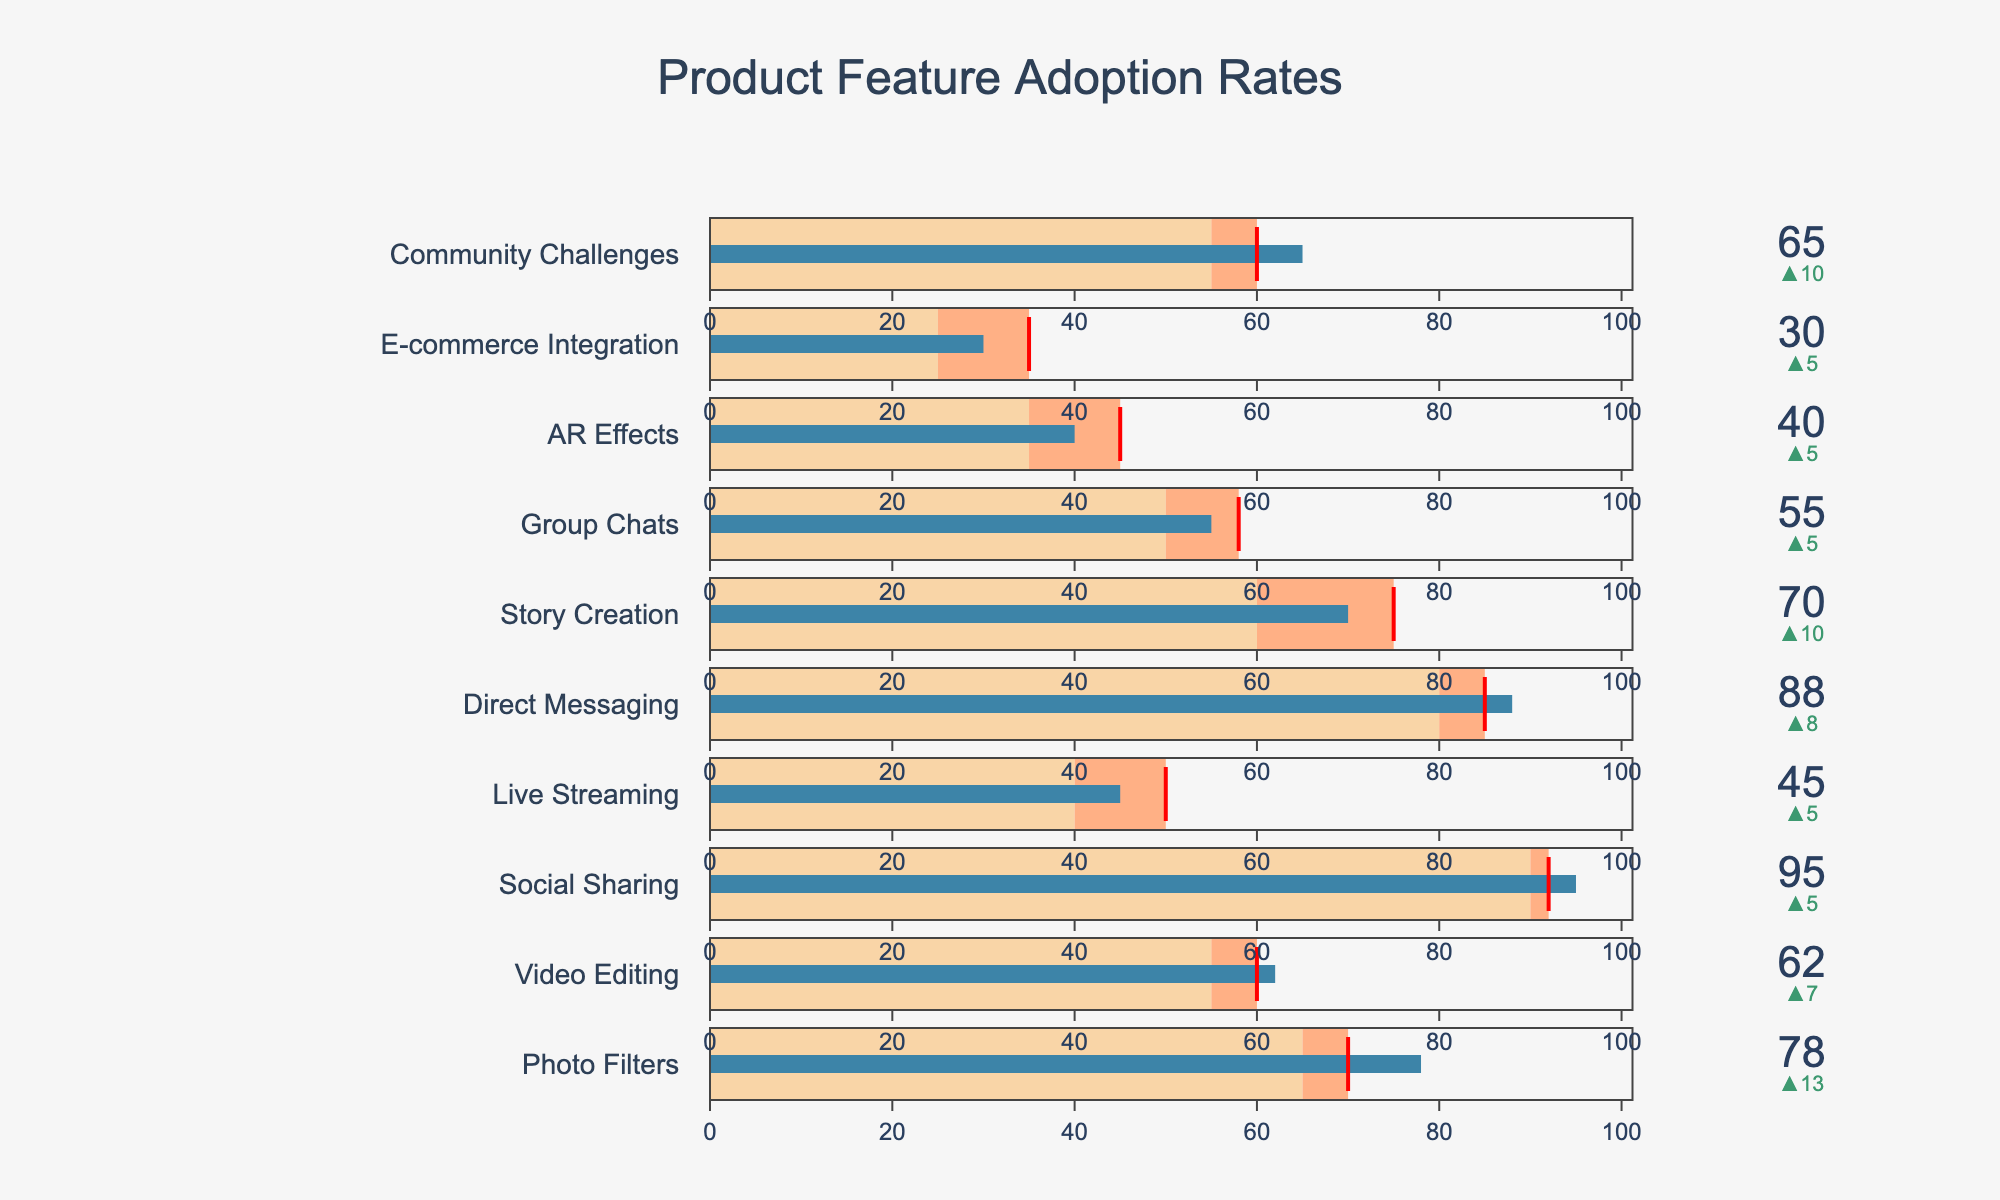What's the title of the figure? The title is located at the top of the figure and is usually in a larger font size with a more prominent color compared to other text elements.
Answer: Product Feature Adoption Rates How many features are displayed in the figure? To determine this, count the number of bullet charts or indicators present in the figure. Each one corresponds to a different feature.
Answer: 10 Which feature has the highest actual adoption rate? Look for the bullet chart with the highest value in the "Actual Adoption" section.
Answer: Social Sharing Which feature has a lower actual adoption rate than its comparison benchmark but higher than its projected adoption rate? Identify the features by comparing actual adoption values to both projected adoption and comparison benchmark values. "Group Chats" has an actual adoption rate (55) lower than its comparison benchmark (58) but higher than its projected adoption rate (50).
Answer: Group Chats What is the difference between the actual adoption rate and the projected adoption rate for E-commerce Integration? Find and subtract the projected adoption rate from the actual adoption rate for E-commerce Integration. 30 (actual) - 25 (projected) = 5
Answer: 5 Which feature has the smallest range between its actual adoption and its projected adoption rate? Calculate the range between actual adoption and projected adoption for each feature, then find the smallest. AR Effects: 40 - 35 = 5
Answer: AR Effects By how much does the actual adoption rate of Direct Messaging exceed its projected adoption rate? Subtract the projected adoption rate from the actual adoption rate for Direct Messaging. 88 (actual) - 80 (projected) = 8
Answer: 8 Compare Live Streaming and Story Creation: which one has a higher actual adoption rate and by how much? Compare the actual adoption rates of both features. 70 (Story Creation) - 45 (Live Streaming) = 25
Answer: Story Creation by 25 Among all features, which one has the actual adoption rate closest to its comparison benchmark? Calculate the absolute difference between the actual adoption rates and comparison benchmarks for each feature, and find the smallest one. Direct Messaging has an actual adoption rate of 88, and its benchmark is 85, with a difference of 3.
Answer: Direct Messaging What's the average projected adoption rate among all features? Sum the projected adoption rates of all features and divide by the number of features. (65 + 55 + 90 + 40 + 80 + 60 + 50 + 35 + 25 + 55) / 10 = 55.5
Answer: 55.5 